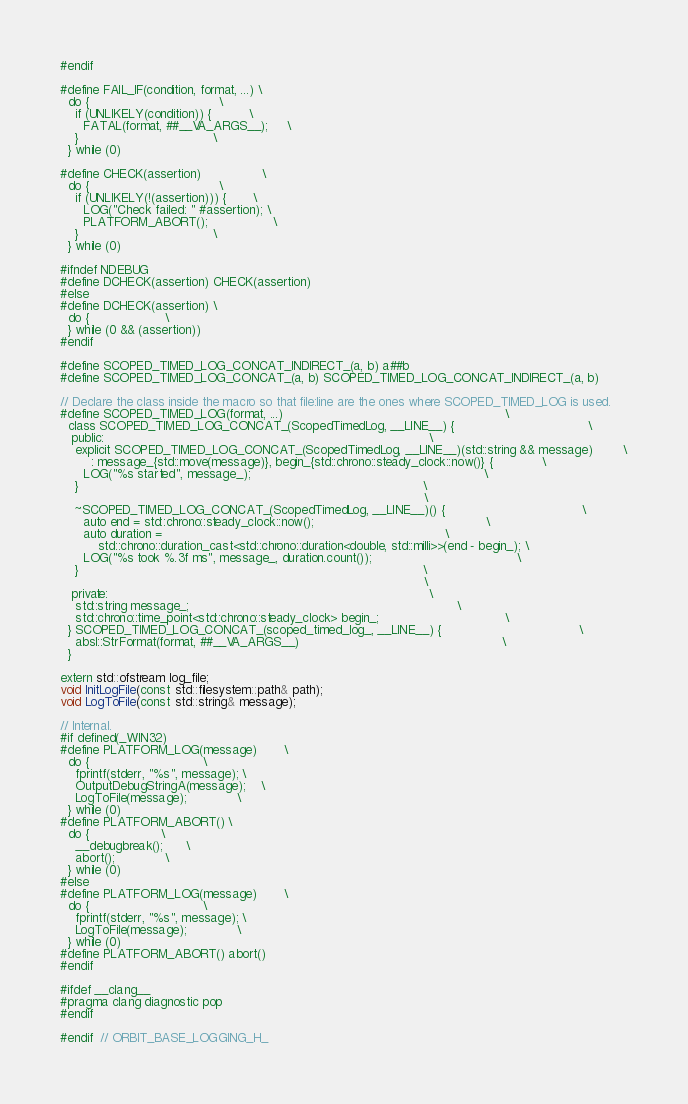Convert code to text. <code><loc_0><loc_0><loc_500><loc_500><_C_>#endif

#define FAIL_IF(condition, format, ...) \
  do {                                  \
    if (UNLIKELY(condition)) {          \
      FATAL(format, ##__VA_ARGS__);     \
    }                                   \
  } while (0)

#define CHECK(assertion)                \
  do {                                  \
    if (UNLIKELY(!(assertion))) {       \
      LOG("Check failed: " #assertion); \
      PLATFORM_ABORT();                 \
    }                                   \
  } while (0)

#ifndef NDEBUG
#define DCHECK(assertion) CHECK(assertion)
#else
#define DCHECK(assertion) \
  do {                    \
  } while (0 && (assertion))
#endif

#define SCOPED_TIMED_LOG_CONCAT_INDIRECT_(a, b) a##b
#define SCOPED_TIMED_LOG_CONCAT_(a, b) SCOPED_TIMED_LOG_CONCAT_INDIRECT_(a, b)

// Declare the class inside the macro so that file:line are the ones where SCOPED_TIMED_LOG is used.
#define SCOPED_TIMED_LOG(format, ...)                                                          \
  class SCOPED_TIMED_LOG_CONCAT_(ScopedTimedLog, __LINE__) {                                   \
   public:                                                                                     \
    explicit SCOPED_TIMED_LOG_CONCAT_(ScopedTimedLog, __LINE__)(std::string && message)        \
        : message_{std::move(message)}, begin_{std::chrono::steady_clock::now()} {             \
      LOG("%s started", message_);                                                             \
    }                                                                                          \
                                                                                               \
    ~SCOPED_TIMED_LOG_CONCAT_(ScopedTimedLog, __LINE__)() {                                    \
      auto end = std::chrono::steady_clock::now();                                             \
      auto duration =                                                                          \
          std::chrono::duration_cast<std::chrono::duration<double, std::milli>>(end - begin_); \
      LOG("%s took %.3f ms", message_, duration.count());                                      \
    }                                                                                          \
                                                                                               \
   private:                                                                                    \
    std::string message_;                                                                      \
    std::chrono::time_point<std::chrono::steady_clock> begin_;                                 \
  } SCOPED_TIMED_LOG_CONCAT_(scoped_timed_log_, __LINE__) {                                    \
    absl::StrFormat(format, ##__VA_ARGS__)                                                     \
  }

extern std::ofstream log_file;
void InitLogFile(const std::filesystem::path& path);
void LogToFile(const std::string& message);

// Internal.
#if defined(_WIN32)
#define PLATFORM_LOG(message)       \
  do {                              \
    fprintf(stderr, "%s", message); \
    OutputDebugStringA(message);    \
    LogToFile(message);             \
  } while (0)
#define PLATFORM_ABORT() \
  do {                   \
    __debugbreak();      \
    abort();             \
  } while (0)
#else
#define PLATFORM_LOG(message)       \
  do {                              \
    fprintf(stderr, "%s", message); \
    LogToFile(message);             \
  } while (0)
#define PLATFORM_ABORT() abort()
#endif

#ifdef __clang__
#pragma clang diagnostic pop
#endif

#endif  // ORBIT_BASE_LOGGING_H_
</code> 